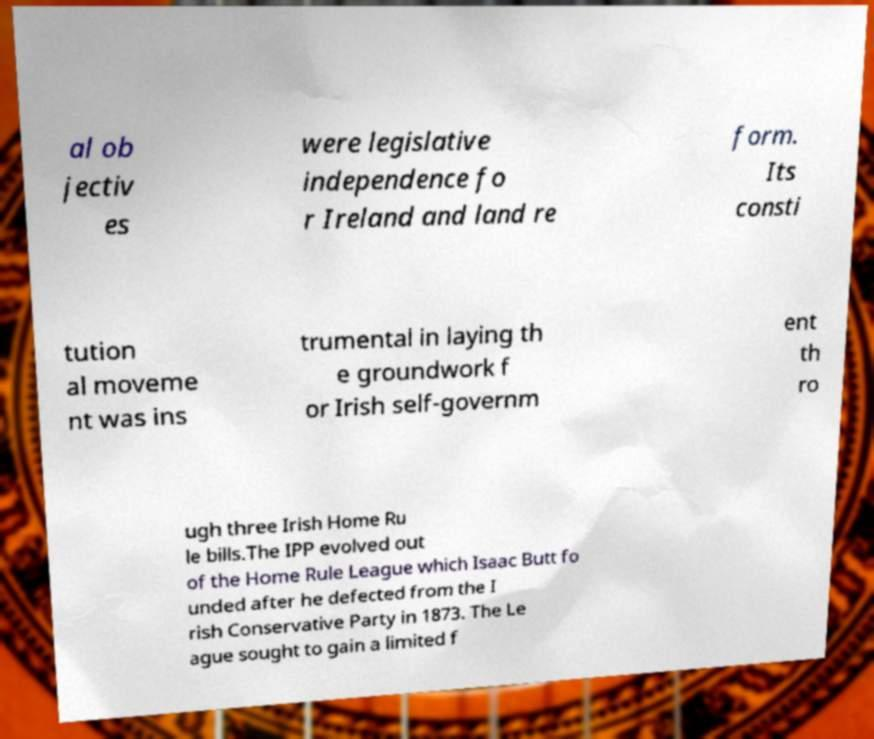I need the written content from this picture converted into text. Can you do that? al ob jectiv es were legislative independence fo r Ireland and land re form. Its consti tution al moveme nt was ins trumental in laying th e groundwork f or Irish self-governm ent th ro ugh three Irish Home Ru le bills.The IPP evolved out of the Home Rule League which Isaac Butt fo unded after he defected from the I rish Conservative Party in 1873. The Le ague sought to gain a limited f 